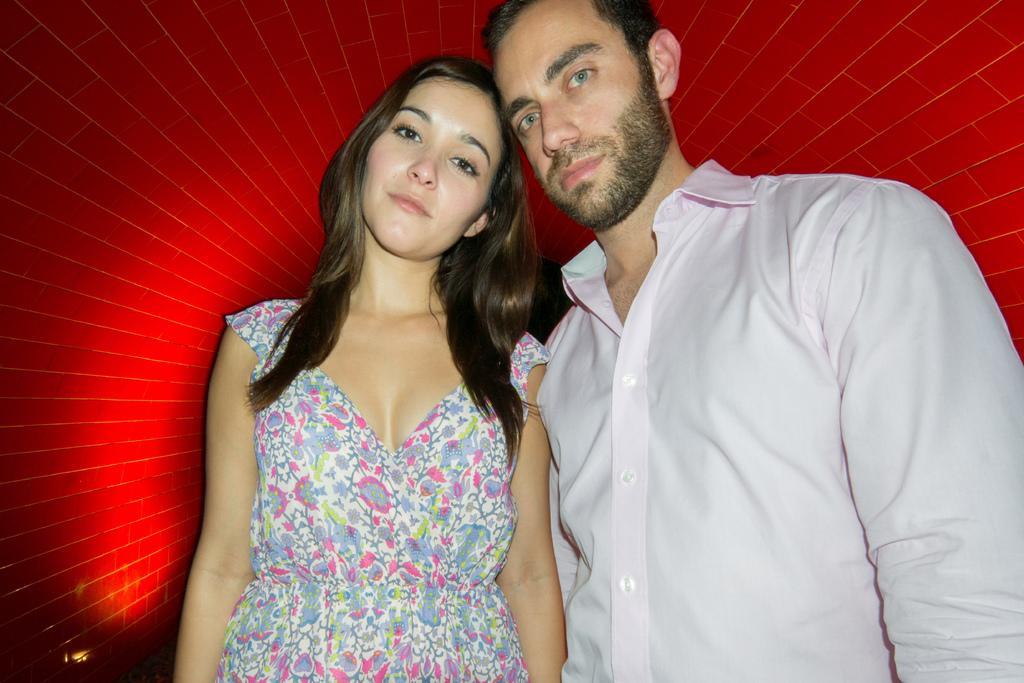Describe this image in one or two sentences. In this image we can see a man and a woman standing. 